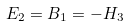<formula> <loc_0><loc_0><loc_500><loc_500>E _ { 2 } = B _ { 1 } = - H _ { 3 }</formula> 